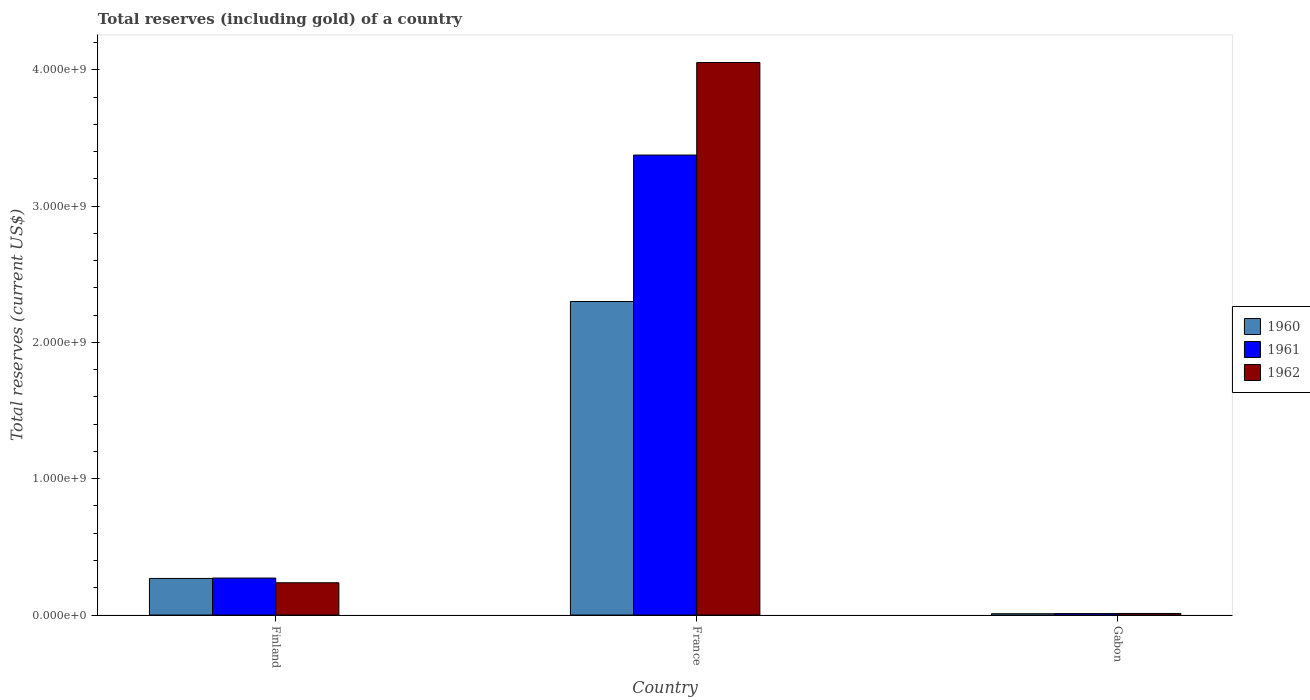How many different coloured bars are there?
Your answer should be very brief. 3. How many bars are there on the 1st tick from the left?
Offer a very short reply. 3. In how many cases, is the number of bars for a given country not equal to the number of legend labels?
Keep it short and to the point. 0. What is the total reserves (including gold) in 1962 in Gabon?
Give a very brief answer. 1.12e+07. Across all countries, what is the maximum total reserves (including gold) in 1961?
Offer a very short reply. 3.37e+09. Across all countries, what is the minimum total reserves (including gold) in 1960?
Your answer should be very brief. 9.50e+06. In which country was the total reserves (including gold) in 1962 maximum?
Offer a very short reply. France. In which country was the total reserves (including gold) in 1962 minimum?
Your answer should be compact. Gabon. What is the total total reserves (including gold) in 1961 in the graph?
Make the answer very short. 3.66e+09. What is the difference between the total reserves (including gold) in 1961 in Finland and that in Gabon?
Offer a terse response. 2.60e+08. What is the difference between the total reserves (including gold) in 1960 in France and the total reserves (including gold) in 1961 in Gabon?
Your answer should be compact. 2.29e+09. What is the average total reserves (including gold) in 1961 per country?
Offer a very short reply. 1.22e+09. What is the difference between the total reserves (including gold) of/in 1962 and total reserves (including gold) of/in 1961 in France?
Your answer should be compact. 6.79e+08. In how many countries, is the total reserves (including gold) in 1961 greater than 2800000000 US$?
Make the answer very short. 1. What is the ratio of the total reserves (including gold) in 1961 in France to that in Gabon?
Give a very brief answer. 315.38. Is the total reserves (including gold) in 1961 in France less than that in Gabon?
Provide a succinct answer. No. What is the difference between the highest and the second highest total reserves (including gold) in 1962?
Give a very brief answer. -4.04e+09. What is the difference between the highest and the lowest total reserves (including gold) in 1960?
Give a very brief answer. 2.29e+09. What does the 2nd bar from the left in France represents?
Provide a succinct answer. 1961. Is it the case that in every country, the sum of the total reserves (including gold) in 1961 and total reserves (including gold) in 1962 is greater than the total reserves (including gold) in 1960?
Your response must be concise. Yes. How many bars are there?
Give a very brief answer. 9. How many countries are there in the graph?
Ensure brevity in your answer.  3. Are the values on the major ticks of Y-axis written in scientific E-notation?
Your answer should be very brief. Yes. Where does the legend appear in the graph?
Keep it short and to the point. Center right. How many legend labels are there?
Keep it short and to the point. 3. What is the title of the graph?
Make the answer very short. Total reserves (including gold) of a country. Does "1989" appear as one of the legend labels in the graph?
Provide a succinct answer. No. What is the label or title of the Y-axis?
Give a very brief answer. Total reserves (current US$). What is the Total reserves (current US$) in 1960 in Finland?
Offer a terse response. 2.68e+08. What is the Total reserves (current US$) in 1961 in Finland?
Your answer should be very brief. 2.71e+08. What is the Total reserves (current US$) of 1962 in Finland?
Give a very brief answer. 2.37e+08. What is the Total reserves (current US$) of 1960 in France?
Provide a succinct answer. 2.30e+09. What is the Total reserves (current US$) of 1961 in France?
Make the answer very short. 3.37e+09. What is the Total reserves (current US$) of 1962 in France?
Offer a very short reply. 4.05e+09. What is the Total reserves (current US$) of 1960 in Gabon?
Ensure brevity in your answer.  9.50e+06. What is the Total reserves (current US$) in 1961 in Gabon?
Your answer should be compact. 1.07e+07. What is the Total reserves (current US$) in 1962 in Gabon?
Make the answer very short. 1.12e+07. Across all countries, what is the maximum Total reserves (current US$) of 1960?
Make the answer very short. 2.30e+09. Across all countries, what is the maximum Total reserves (current US$) of 1961?
Ensure brevity in your answer.  3.37e+09. Across all countries, what is the maximum Total reserves (current US$) of 1962?
Keep it short and to the point. 4.05e+09. Across all countries, what is the minimum Total reserves (current US$) of 1960?
Offer a very short reply. 9.50e+06. Across all countries, what is the minimum Total reserves (current US$) of 1961?
Give a very brief answer. 1.07e+07. Across all countries, what is the minimum Total reserves (current US$) of 1962?
Provide a succinct answer. 1.12e+07. What is the total Total reserves (current US$) of 1960 in the graph?
Offer a terse response. 2.58e+09. What is the total Total reserves (current US$) of 1961 in the graph?
Make the answer very short. 3.66e+09. What is the total Total reserves (current US$) of 1962 in the graph?
Your response must be concise. 4.30e+09. What is the difference between the Total reserves (current US$) of 1960 in Finland and that in France?
Provide a succinct answer. -2.03e+09. What is the difference between the Total reserves (current US$) in 1961 in Finland and that in France?
Make the answer very short. -3.10e+09. What is the difference between the Total reserves (current US$) in 1962 in Finland and that in France?
Make the answer very short. -3.82e+09. What is the difference between the Total reserves (current US$) in 1960 in Finland and that in Gabon?
Give a very brief answer. 2.59e+08. What is the difference between the Total reserves (current US$) in 1961 in Finland and that in Gabon?
Give a very brief answer. 2.60e+08. What is the difference between the Total reserves (current US$) in 1962 in Finland and that in Gabon?
Provide a short and direct response. 2.25e+08. What is the difference between the Total reserves (current US$) in 1960 in France and that in Gabon?
Provide a short and direct response. 2.29e+09. What is the difference between the Total reserves (current US$) in 1961 in France and that in Gabon?
Offer a terse response. 3.36e+09. What is the difference between the Total reserves (current US$) of 1962 in France and that in Gabon?
Give a very brief answer. 4.04e+09. What is the difference between the Total reserves (current US$) of 1960 in Finland and the Total reserves (current US$) of 1961 in France?
Your answer should be very brief. -3.11e+09. What is the difference between the Total reserves (current US$) in 1960 in Finland and the Total reserves (current US$) in 1962 in France?
Offer a very short reply. -3.79e+09. What is the difference between the Total reserves (current US$) in 1961 in Finland and the Total reserves (current US$) in 1962 in France?
Make the answer very short. -3.78e+09. What is the difference between the Total reserves (current US$) in 1960 in Finland and the Total reserves (current US$) in 1961 in Gabon?
Provide a succinct answer. 2.58e+08. What is the difference between the Total reserves (current US$) of 1960 in Finland and the Total reserves (current US$) of 1962 in Gabon?
Your answer should be compact. 2.57e+08. What is the difference between the Total reserves (current US$) of 1961 in Finland and the Total reserves (current US$) of 1962 in Gabon?
Offer a terse response. 2.60e+08. What is the difference between the Total reserves (current US$) of 1960 in France and the Total reserves (current US$) of 1961 in Gabon?
Give a very brief answer. 2.29e+09. What is the difference between the Total reserves (current US$) of 1960 in France and the Total reserves (current US$) of 1962 in Gabon?
Ensure brevity in your answer.  2.29e+09. What is the difference between the Total reserves (current US$) of 1961 in France and the Total reserves (current US$) of 1962 in Gabon?
Keep it short and to the point. 3.36e+09. What is the average Total reserves (current US$) in 1960 per country?
Provide a short and direct response. 8.59e+08. What is the average Total reserves (current US$) of 1961 per country?
Your answer should be compact. 1.22e+09. What is the average Total reserves (current US$) of 1962 per country?
Your answer should be very brief. 1.43e+09. What is the difference between the Total reserves (current US$) in 1960 and Total reserves (current US$) in 1961 in Finland?
Offer a very short reply. -2.81e+06. What is the difference between the Total reserves (current US$) in 1960 and Total reserves (current US$) in 1962 in Finland?
Make the answer very short. 3.17e+07. What is the difference between the Total reserves (current US$) of 1961 and Total reserves (current US$) of 1962 in Finland?
Make the answer very short. 3.45e+07. What is the difference between the Total reserves (current US$) of 1960 and Total reserves (current US$) of 1961 in France?
Offer a very short reply. -1.07e+09. What is the difference between the Total reserves (current US$) in 1960 and Total reserves (current US$) in 1962 in France?
Offer a terse response. -1.75e+09. What is the difference between the Total reserves (current US$) of 1961 and Total reserves (current US$) of 1962 in France?
Ensure brevity in your answer.  -6.79e+08. What is the difference between the Total reserves (current US$) of 1960 and Total reserves (current US$) of 1961 in Gabon?
Offer a terse response. -1.20e+06. What is the difference between the Total reserves (current US$) of 1960 and Total reserves (current US$) of 1962 in Gabon?
Provide a succinct answer. -1.75e+06. What is the difference between the Total reserves (current US$) of 1961 and Total reserves (current US$) of 1962 in Gabon?
Provide a short and direct response. -5.50e+05. What is the ratio of the Total reserves (current US$) of 1960 in Finland to that in France?
Give a very brief answer. 0.12. What is the ratio of the Total reserves (current US$) of 1961 in Finland to that in France?
Offer a very short reply. 0.08. What is the ratio of the Total reserves (current US$) in 1962 in Finland to that in France?
Make the answer very short. 0.06. What is the ratio of the Total reserves (current US$) in 1960 in Finland to that in Gabon?
Your answer should be compact. 28.25. What is the ratio of the Total reserves (current US$) of 1961 in Finland to that in Gabon?
Your answer should be compact. 25.34. What is the ratio of the Total reserves (current US$) of 1962 in Finland to that in Gabon?
Make the answer very short. 21.04. What is the ratio of the Total reserves (current US$) in 1960 in France to that in Gabon?
Your answer should be very brief. 242.13. What is the ratio of the Total reserves (current US$) of 1961 in France to that in Gabon?
Make the answer very short. 315.38. What is the ratio of the Total reserves (current US$) of 1962 in France to that in Gabon?
Offer a very short reply. 360.32. What is the difference between the highest and the second highest Total reserves (current US$) in 1960?
Provide a succinct answer. 2.03e+09. What is the difference between the highest and the second highest Total reserves (current US$) of 1961?
Offer a very short reply. 3.10e+09. What is the difference between the highest and the second highest Total reserves (current US$) in 1962?
Your answer should be compact. 3.82e+09. What is the difference between the highest and the lowest Total reserves (current US$) of 1960?
Provide a short and direct response. 2.29e+09. What is the difference between the highest and the lowest Total reserves (current US$) of 1961?
Keep it short and to the point. 3.36e+09. What is the difference between the highest and the lowest Total reserves (current US$) in 1962?
Keep it short and to the point. 4.04e+09. 